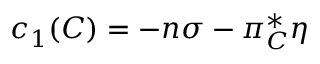<formula> <loc_0><loc_0><loc_500><loc_500>c _ { 1 } ( C ) = - n \sigma - \pi _ { C } ^ { * } \eta</formula> 